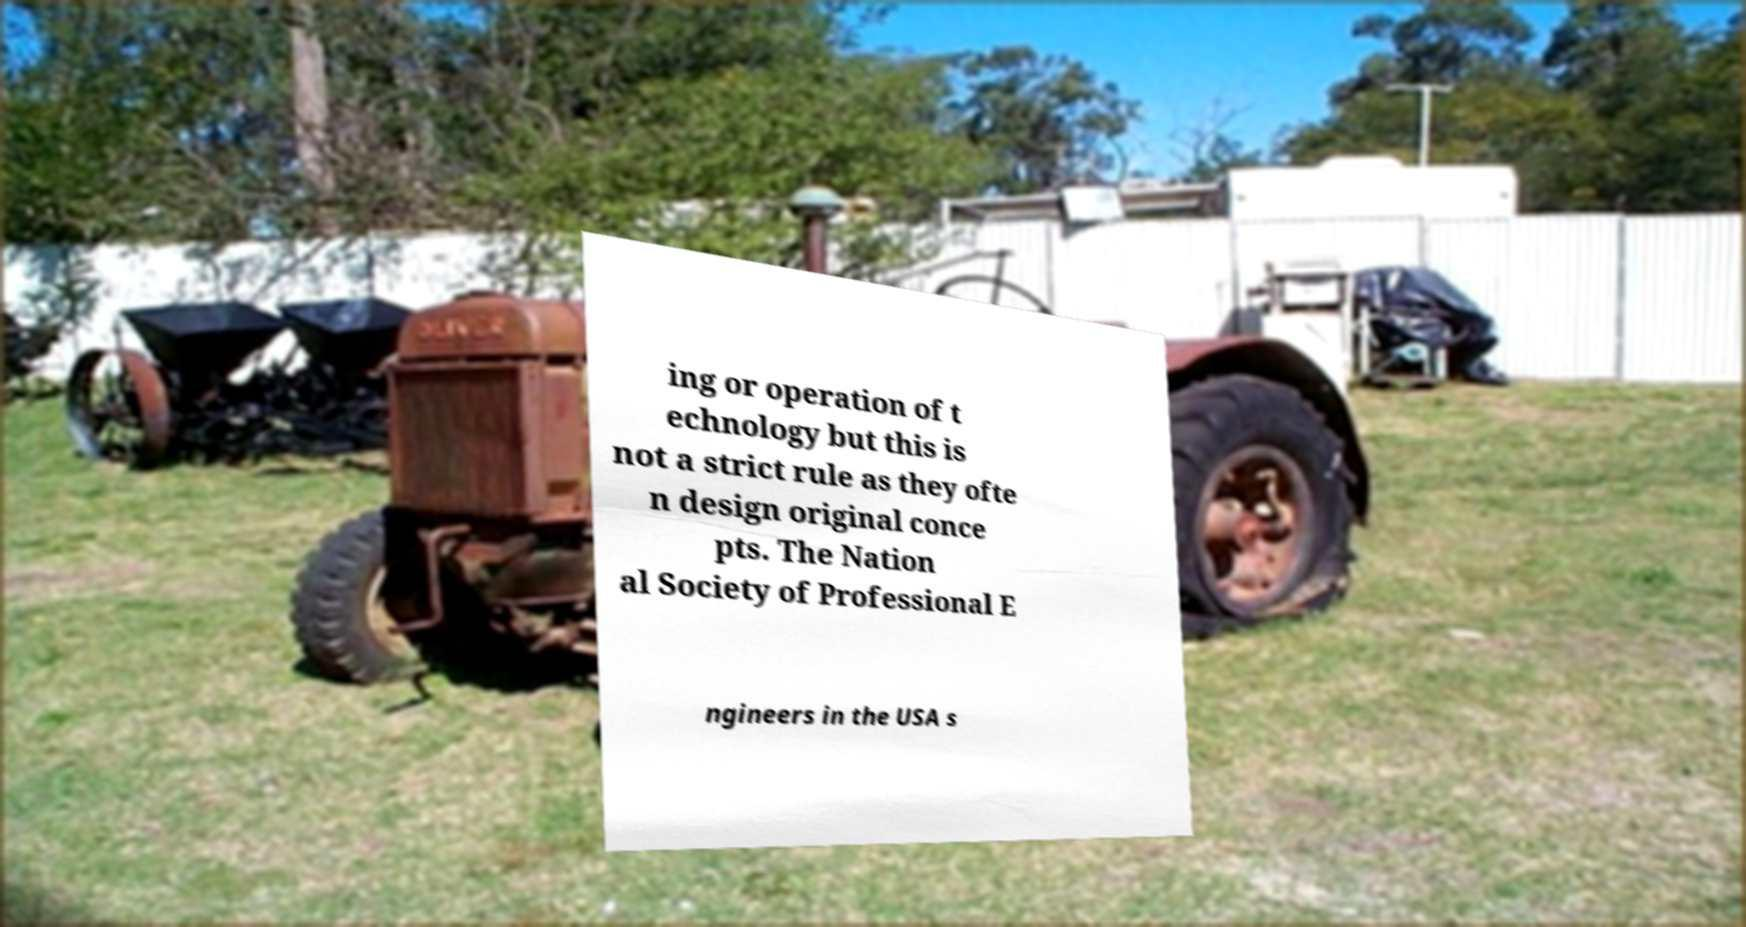Can you read and provide the text displayed in the image?This photo seems to have some interesting text. Can you extract and type it out for me? ing or operation of t echnology but this is not a strict rule as they ofte n design original conce pts. The Nation al Society of Professional E ngineers in the USA s 